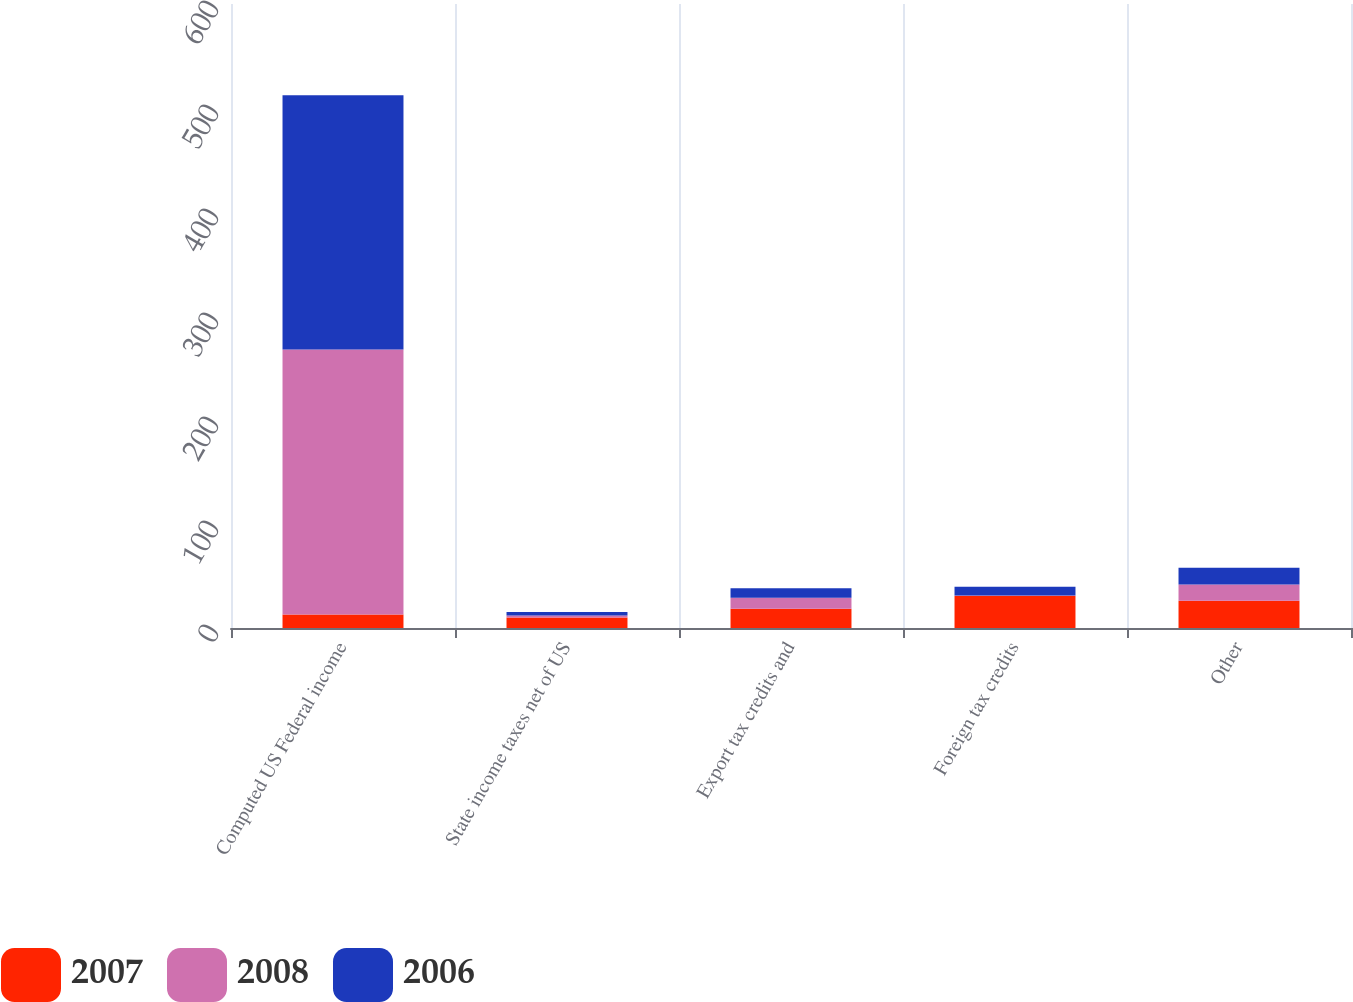Convert chart. <chart><loc_0><loc_0><loc_500><loc_500><stacked_bar_chart><ecel><fcel>Computed US Federal income<fcel>State income taxes net of US<fcel>Export tax credits and<fcel>Foreign tax credits<fcel>Other<nl><fcel>2007<fcel>13.05<fcel>10.1<fcel>18.6<fcel>30.7<fcel>26.3<nl><fcel>2008<fcel>254.7<fcel>1.9<fcel>10.5<fcel>0.5<fcel>15.6<nl><fcel>2006<fcel>244.5<fcel>3.5<fcel>9.1<fcel>8.5<fcel>16<nl></chart> 